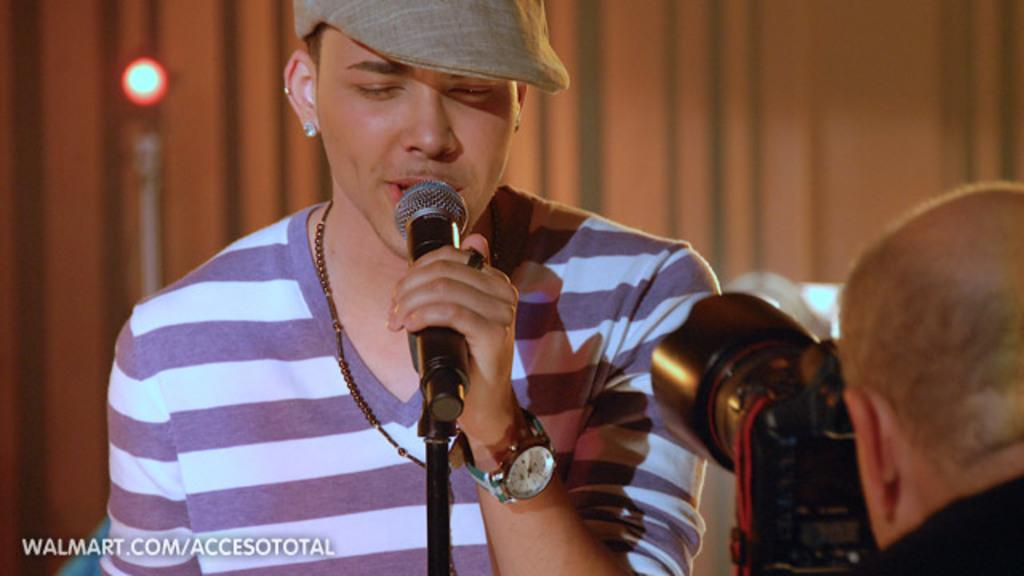What is the person in the image doing? The person is singing a song. What is the person wearing on their head? The person is wearing a cream-colored hat. What object is the person holding? The person is holding a microphone. Can you describe the background of the image? There is a camera and another person in the background of the image. What type of territory does the person's father own in the image? There is no mention of a father or territory in the image. 